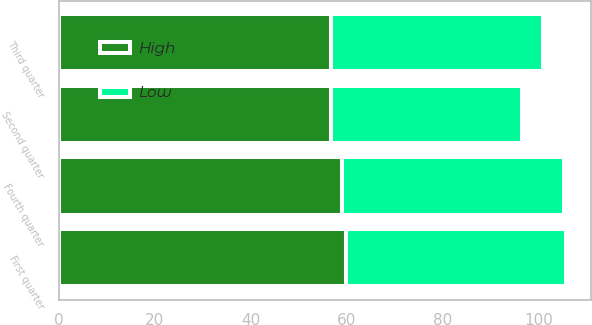Convert chart to OTSL. <chart><loc_0><loc_0><loc_500><loc_500><stacked_bar_chart><ecel><fcel>First quarter<fcel>Second quarter<fcel>Third quarter<fcel>Fourth quarter<nl><fcel>High<fcel>59.81<fcel>56.68<fcel>56.69<fcel>58.97<nl><fcel>Low<fcel>45.86<fcel>39.84<fcel>44.22<fcel>46.3<nl></chart> 